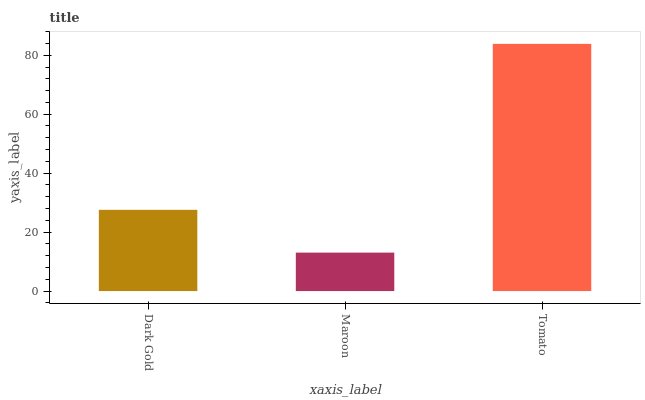Is Maroon the minimum?
Answer yes or no. Yes. Is Tomato the maximum?
Answer yes or no. Yes. Is Tomato the minimum?
Answer yes or no. No. Is Maroon the maximum?
Answer yes or no. No. Is Tomato greater than Maroon?
Answer yes or no. Yes. Is Maroon less than Tomato?
Answer yes or no. Yes. Is Maroon greater than Tomato?
Answer yes or no. No. Is Tomato less than Maroon?
Answer yes or no. No. Is Dark Gold the high median?
Answer yes or no. Yes. Is Dark Gold the low median?
Answer yes or no. Yes. Is Tomato the high median?
Answer yes or no. No. Is Tomato the low median?
Answer yes or no. No. 